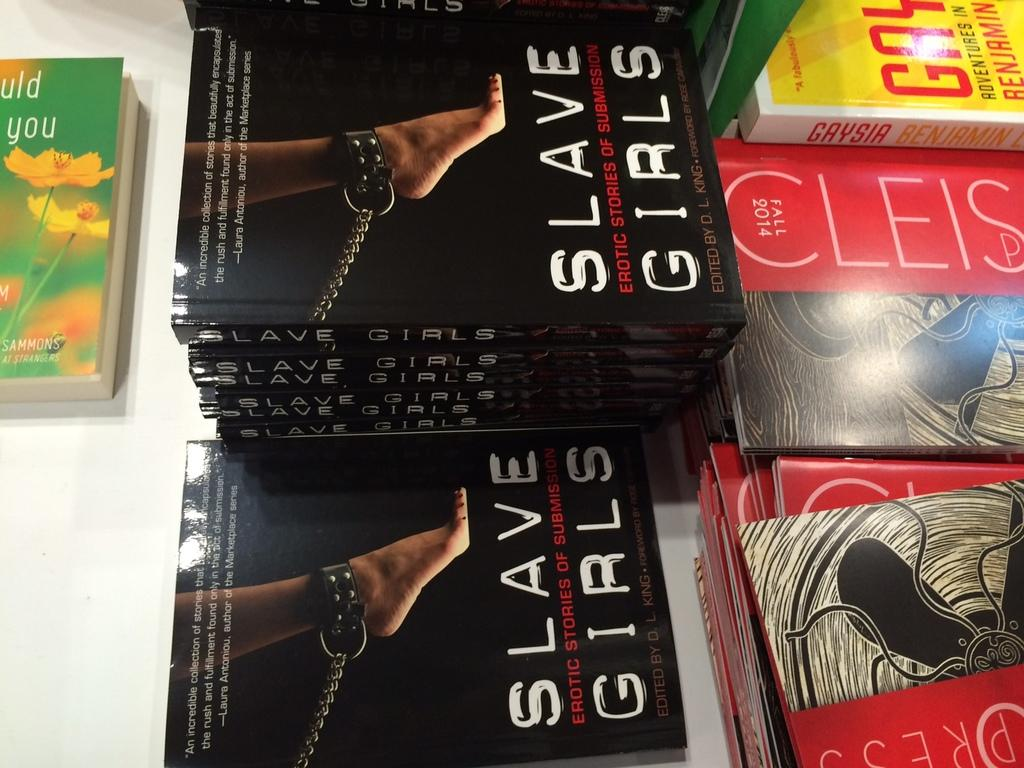<image>
Write a terse but informative summary of the picture. A stack of books titled "Slave Girls." sitting on a white table. 